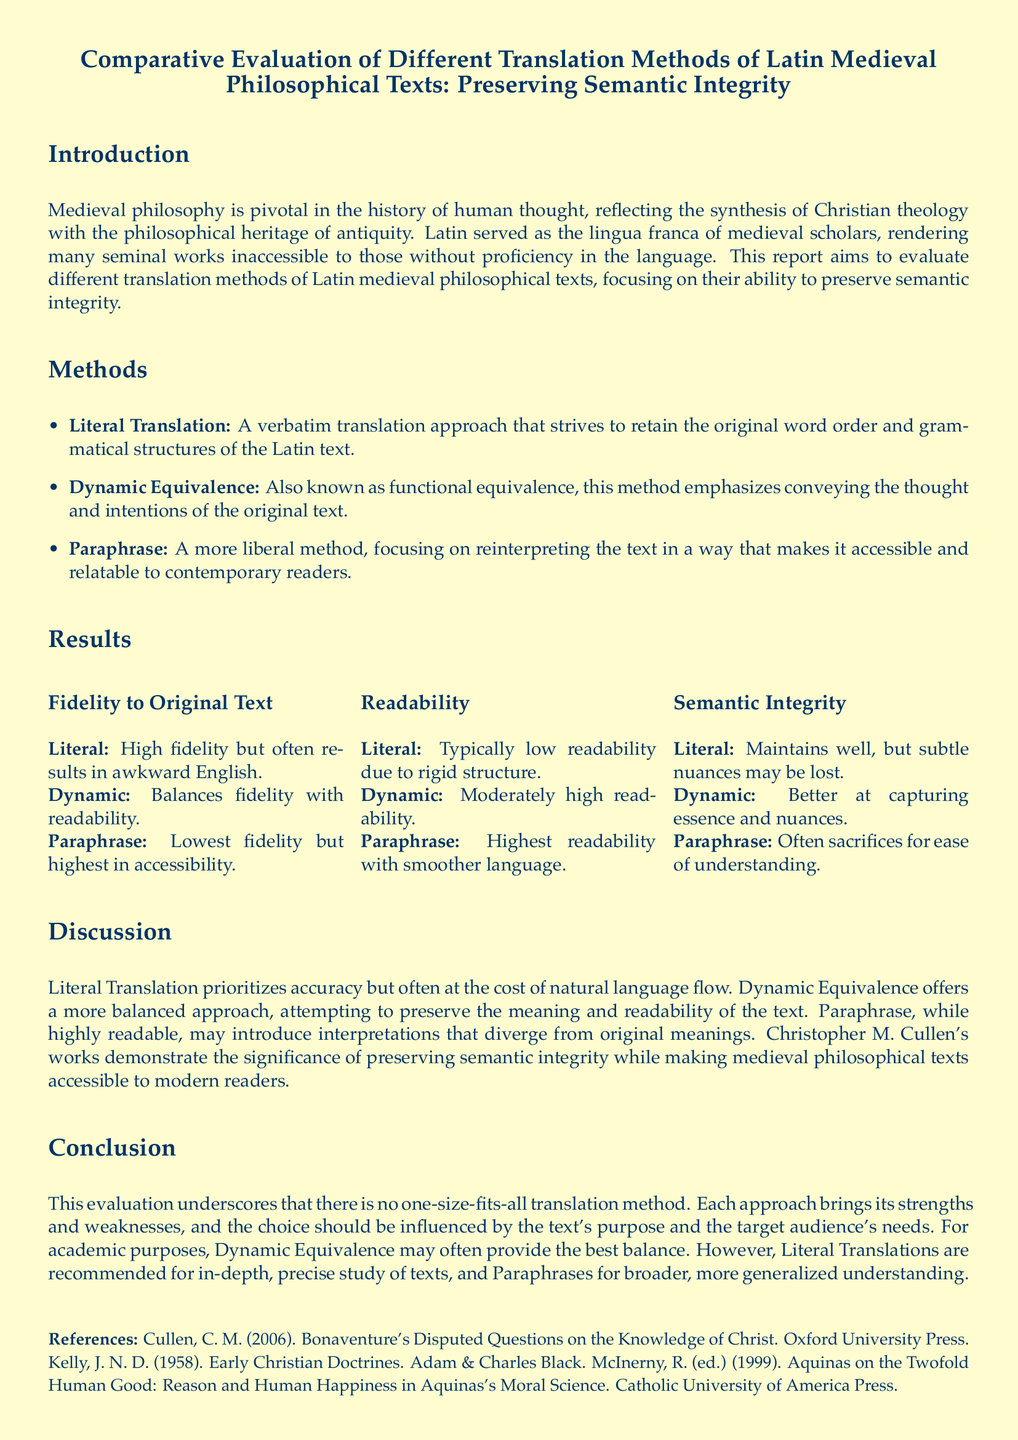What is the title of the report? The title of the report is given at the beginning and identifies the main focus of the research.
Answer: Comparative Evaluation of Different Translation Methods of Latin Medieval Philosophical Texts: Preserving Semantic Integrity What are the three translation methods evaluated? The document lists the translation methods in the methods section.
Answer: Literal Translation, Dynamic Equivalence, Paraphrase Which translation method has the highest fidelity to the original text? The results section indicates fidelity levels for each method.
Answer: Literal What does the document say about Paraphrase related to semantic integrity? The results section specifies the relationship of each method to semantic integrity.
Answer: Often sacrifices for ease of understanding What is emphasized in Dynamic Equivalence regarding readability? The results section discusses readability for each translation method.
Answer: Moderately high readability Which method is recommended for in-depth, precise study of texts? The conclusion summarizes the best use case for each method based on their strengths.
Answer: Literal Translations Who is mentioned as a scholar demonstrating the importance of semantic integrity? The discussion section references an author related to the topic.
Answer: Christopher M. Cullen When was Cullen's reference work published? The references section provides specific publication year details.
Answer: 2006 What does the lab report's evaluation overall emphasize? The conclusion summarizes the overall findings of the evaluation of translation methods.
Answer: There is no one-size-fits-all translation method 